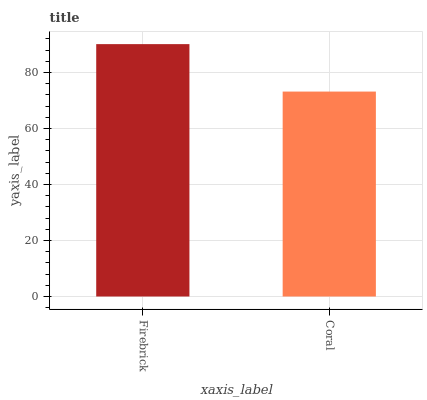Is Firebrick the maximum?
Answer yes or no. Yes. Is Coral the maximum?
Answer yes or no. No. Is Firebrick greater than Coral?
Answer yes or no. Yes. Is Coral less than Firebrick?
Answer yes or no. Yes. Is Coral greater than Firebrick?
Answer yes or no. No. Is Firebrick less than Coral?
Answer yes or no. No. Is Firebrick the high median?
Answer yes or no. Yes. Is Coral the low median?
Answer yes or no. Yes. Is Coral the high median?
Answer yes or no. No. Is Firebrick the low median?
Answer yes or no. No. 